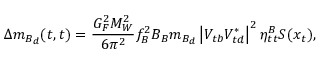Convert formula to latex. <formula><loc_0><loc_0><loc_500><loc_500>\Delta m _ { B _ { d } } ( t , t ) = \frac { G _ { F } ^ { 2 } M _ { W } ^ { 2 } } { 6 \pi ^ { 2 } } f _ { B } ^ { 2 } B _ { B } m _ { B _ { d } } \left | V _ { t b } V _ { t d } ^ { * } \right | ^ { 2 } \eta _ { t t } ^ { B } S ( x _ { t } ) ,</formula> 